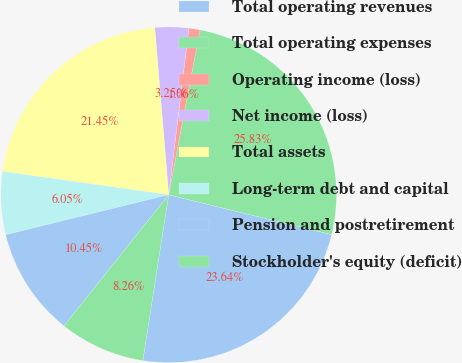Convert chart to OTSL. <chart><loc_0><loc_0><loc_500><loc_500><pie_chart><fcel>Total operating revenues<fcel>Total operating expenses<fcel>Operating income (loss)<fcel>Net income (loss)<fcel>Total assets<fcel>Long-term debt and capital<fcel>Pension and postretirement<fcel>Stockholder's equity (deficit)<nl><fcel>23.64%<fcel>25.83%<fcel>1.06%<fcel>3.25%<fcel>21.45%<fcel>6.05%<fcel>10.45%<fcel>8.26%<nl></chart> 